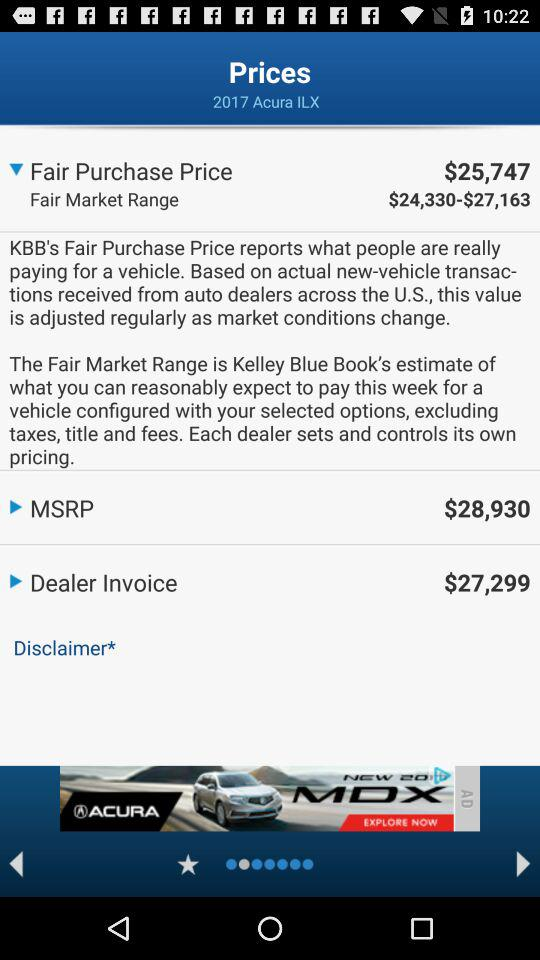What is the year? The year is 2017. 